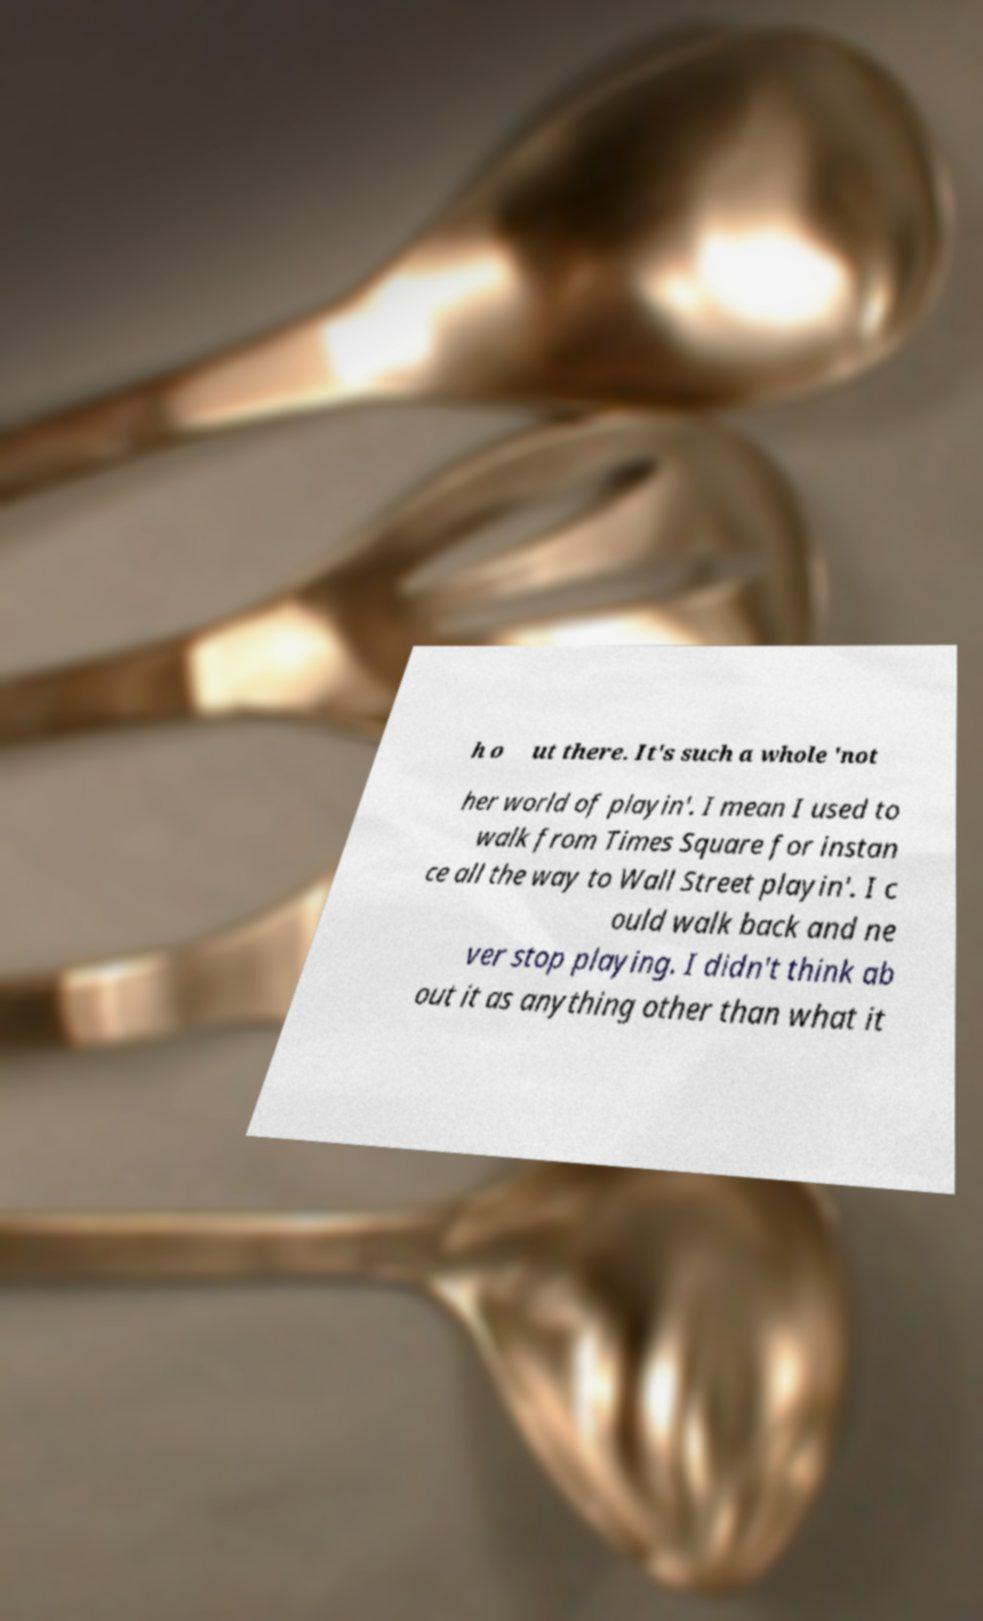Can you accurately transcribe the text from the provided image for me? h o ut there. It's such a whole 'not her world of playin'. I mean I used to walk from Times Square for instan ce all the way to Wall Street playin'. I c ould walk back and ne ver stop playing. I didn't think ab out it as anything other than what it 